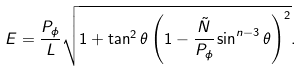<formula> <loc_0><loc_0><loc_500><loc_500>E = \frac { P _ { \phi } } { L } \sqrt { 1 + \tan ^ { 2 } \theta \left ( 1 - { \frac { \tilde { N } } { P _ { \phi } } } \sin ^ { n - 3 } \theta \right ) ^ { 2 } } .</formula> 